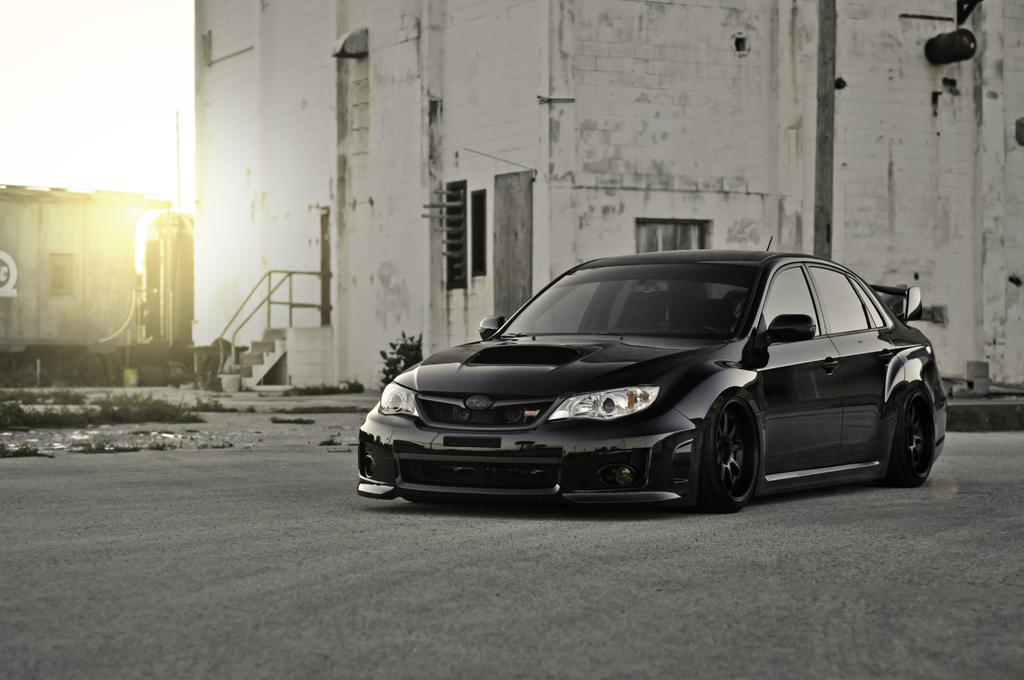What type of vehicle is on the road in the image? There is a black color car on the road in the image. What structures can be seen in the background? There is a building and a house in the background. What other object is present in the background? There is a pole in the background. What type of vegetation is visible in the image? Grass is present in the image. What else can be seen in the image besides the car and background elements? The image consists of a plant. What is the condition of the wall in the image? There is no wall present in the image. How many bits can be seen in the image? There are no bits present in the image. 